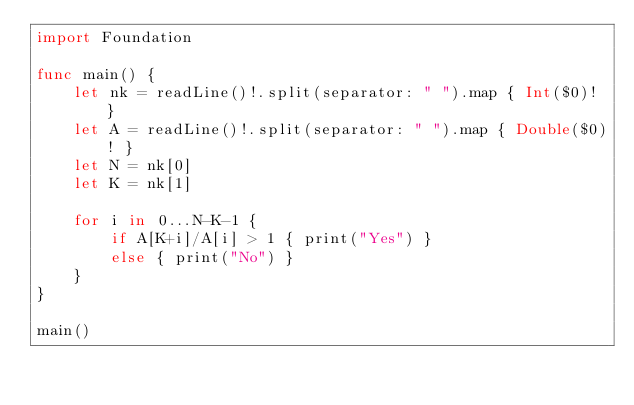<code> <loc_0><loc_0><loc_500><loc_500><_Swift_>import Foundation

func main() {
    let nk = readLine()!.split(separator: " ").map { Int($0)! }
    let A = readLine()!.split(separator: " ").map { Double($0)! }
    let N = nk[0]
    let K = nk[1]
    
    for i in 0...N-K-1 {
        if A[K+i]/A[i] > 1 { print("Yes") }
        else { print("No") }
    }
}

main()
</code> 